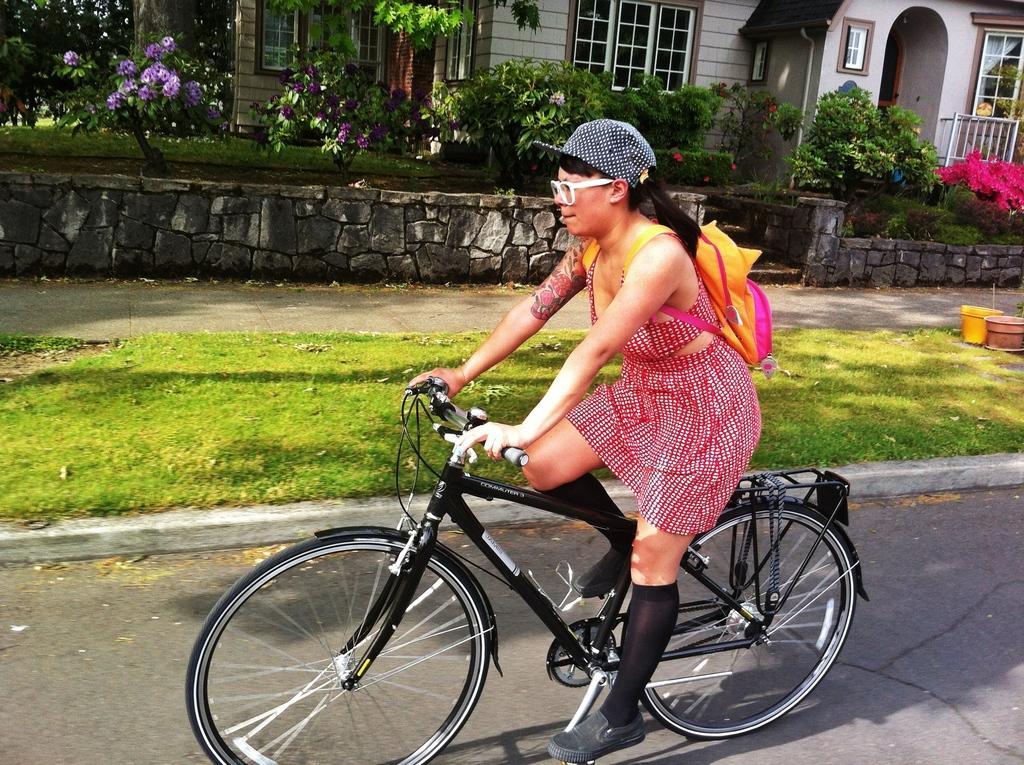Please provide a concise description of this image. In this image I can see a woman is cycling a black color of cycle. I can also see, she is carrying a bag and wearing a cap and specs. In the background I can see few plants and a house. 